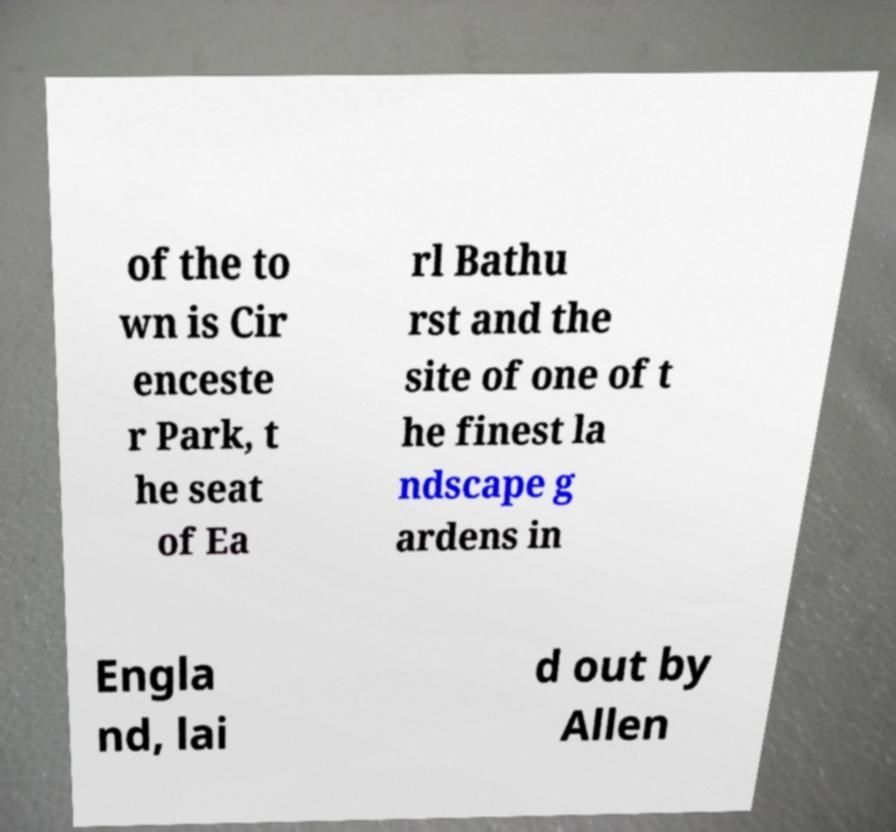Can you accurately transcribe the text from the provided image for me? of the to wn is Cir enceste r Park, t he seat of Ea rl Bathu rst and the site of one of t he finest la ndscape g ardens in Engla nd, lai d out by Allen 